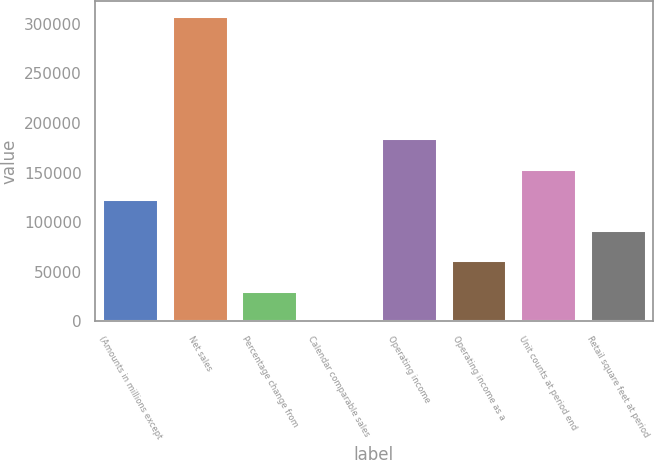Convert chart to OTSL. <chart><loc_0><loc_0><loc_500><loc_500><bar_chart><fcel>(Amounts in millions except<fcel>Net sales<fcel>Percentage change from<fcel>Calendar comparable sales<fcel>Operating income<fcel>Operating income as a<fcel>Unit counts at period end<fcel>Retail square feet at period<nl><fcel>123134<fcel>307833<fcel>30784.7<fcel>1.6<fcel>184700<fcel>61567.9<fcel>153917<fcel>92351<nl></chart> 